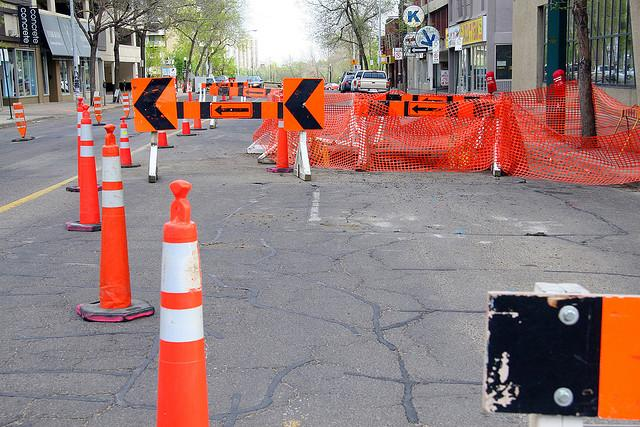Where are repairs taking place here? street 